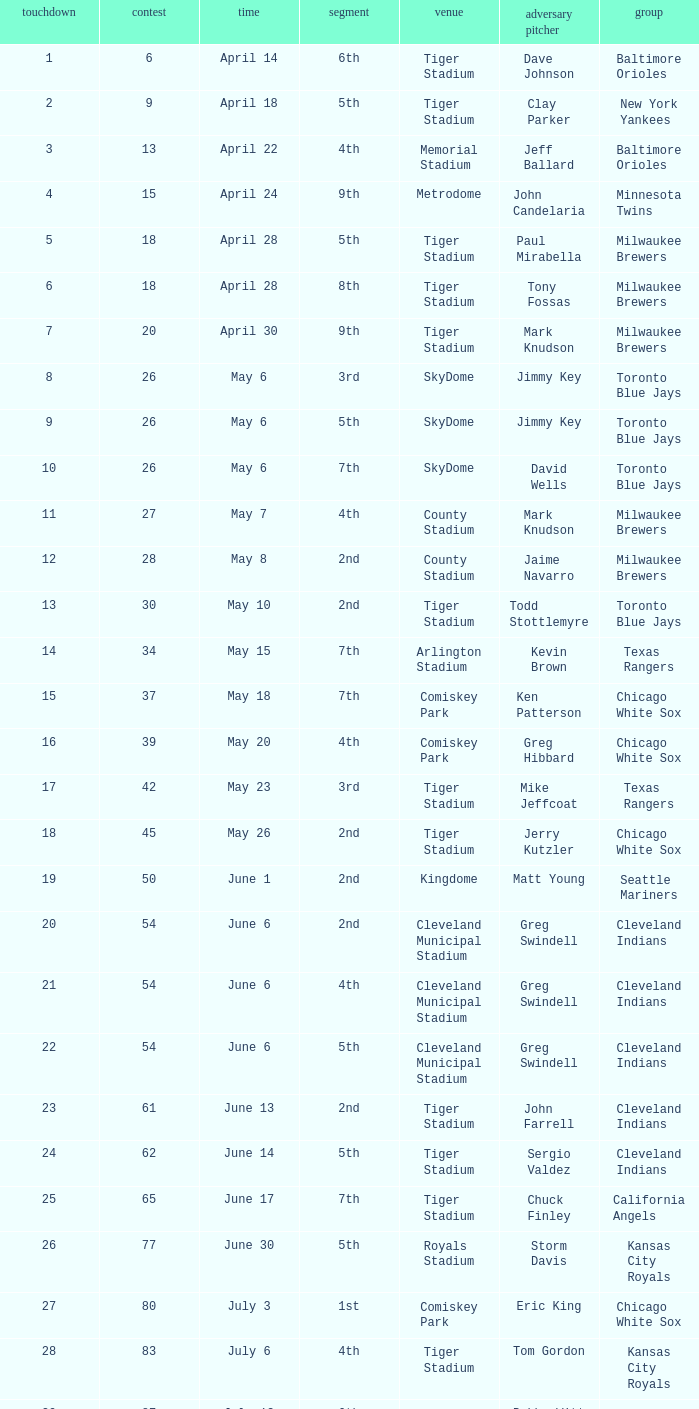When Efrain Valdez was pitching, what was the highest home run? 39.0. 